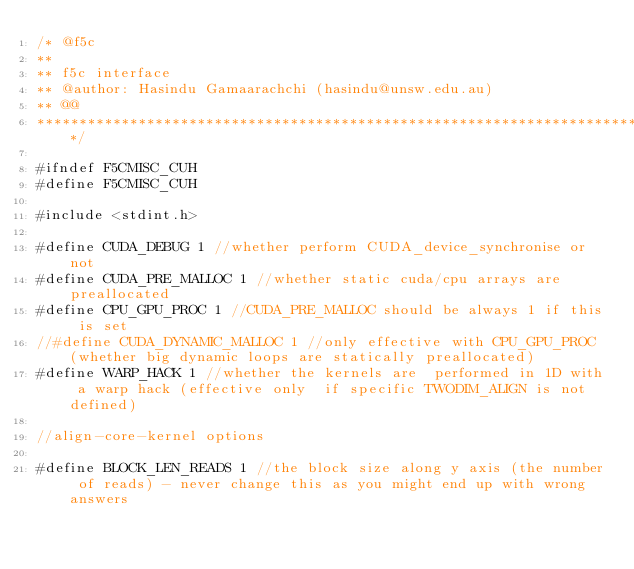<code> <loc_0><loc_0><loc_500><loc_500><_Cuda_>/* @f5c
**
** f5c interface 
** @author: Hasindu Gamaarachchi (hasindu@unsw.edu.au)
** @@
******************************************************************************/

#ifndef F5CMISC_CUH
#define F5CMISC_CUH

#include <stdint.h>

#define CUDA_DEBUG 1 //whether perform CUDA_device_synchronise or not
#define CUDA_PRE_MALLOC 1 //whether static cuda/cpu arrays are preallocated
#define CPU_GPU_PROC 1 //CUDA_PRE_MALLOC should be always 1 if this is set
//#define CUDA_DYNAMIC_MALLOC 1 //only effective with CPU_GPU_PROC (whether big dynamic loops are statically preallocated)
#define WARP_HACK 1 //whether the kernels are  performed in 1D with a warp hack (effective only  if specific TWODIM_ALIGN is not defined)

//align-core-kernel options

#define BLOCK_LEN_READS 1 //the block size along y axis (the number of reads) - never change this as you might end up with wrong answers</code> 